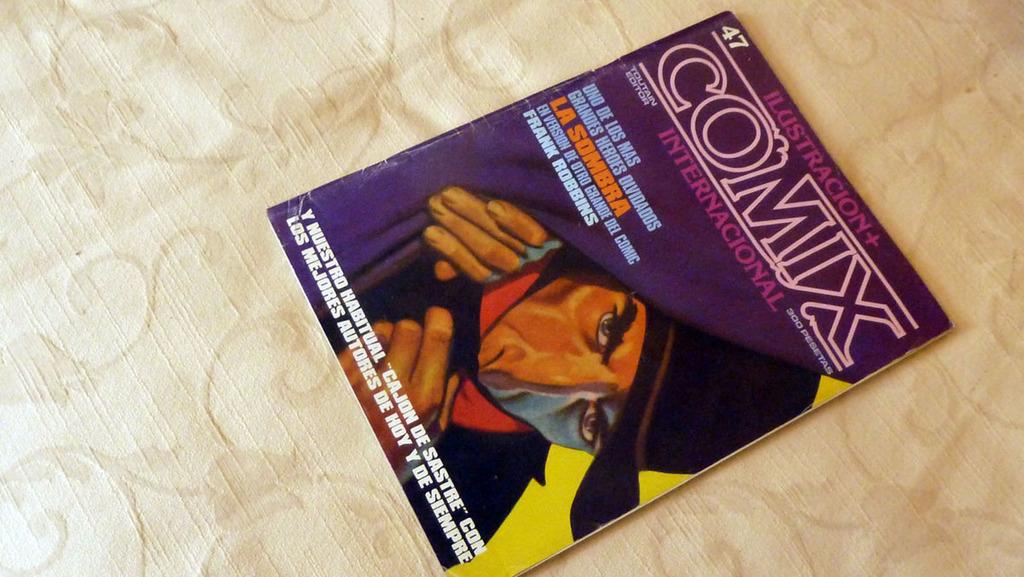<image>
Describe the image concisely. a comic book that says 'ilustracion comix internacional' on it 